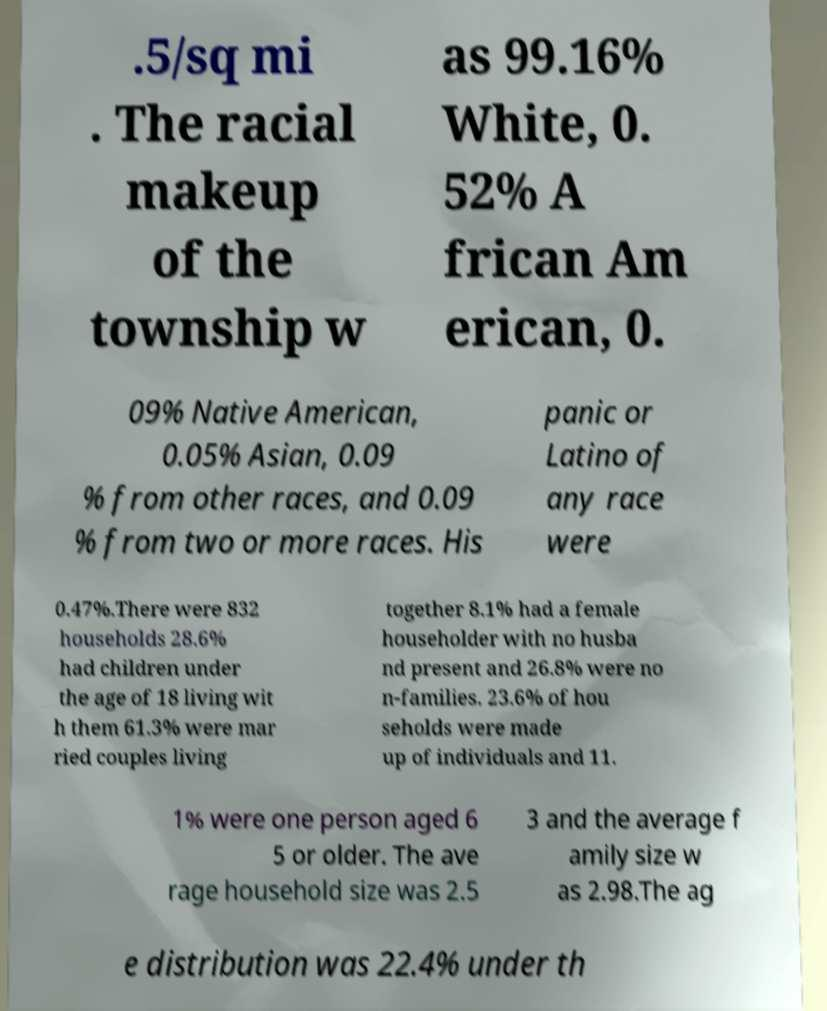Please identify and transcribe the text found in this image. .5/sq mi . The racial makeup of the township w as 99.16% White, 0. 52% A frican Am erican, 0. 09% Native American, 0.05% Asian, 0.09 % from other races, and 0.09 % from two or more races. His panic or Latino of any race were 0.47%.There were 832 households 28.6% had children under the age of 18 living wit h them 61.3% were mar ried couples living together 8.1% had a female householder with no husba nd present and 26.8% were no n-families. 23.6% of hou seholds were made up of individuals and 11. 1% were one person aged 6 5 or older. The ave rage household size was 2.5 3 and the average f amily size w as 2.98.The ag e distribution was 22.4% under th 